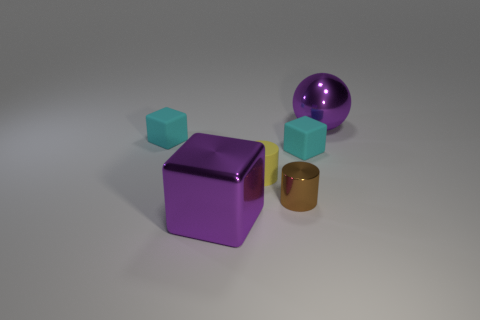Subtract all gray spheres. How many cyan blocks are left? 2 Subtract all small blocks. How many blocks are left? 1 Subtract 1 cubes. How many cubes are left? 2 Add 1 small blue matte spheres. How many objects exist? 7 Subtract all cylinders. How many objects are left? 4 Subtract all green blocks. Subtract all cyan spheres. How many blocks are left? 3 Subtract all metal spheres. Subtract all tiny cubes. How many objects are left? 3 Add 3 purple cubes. How many purple cubes are left? 4 Add 6 small gray matte cylinders. How many small gray matte cylinders exist? 6 Subtract 0 yellow blocks. How many objects are left? 6 